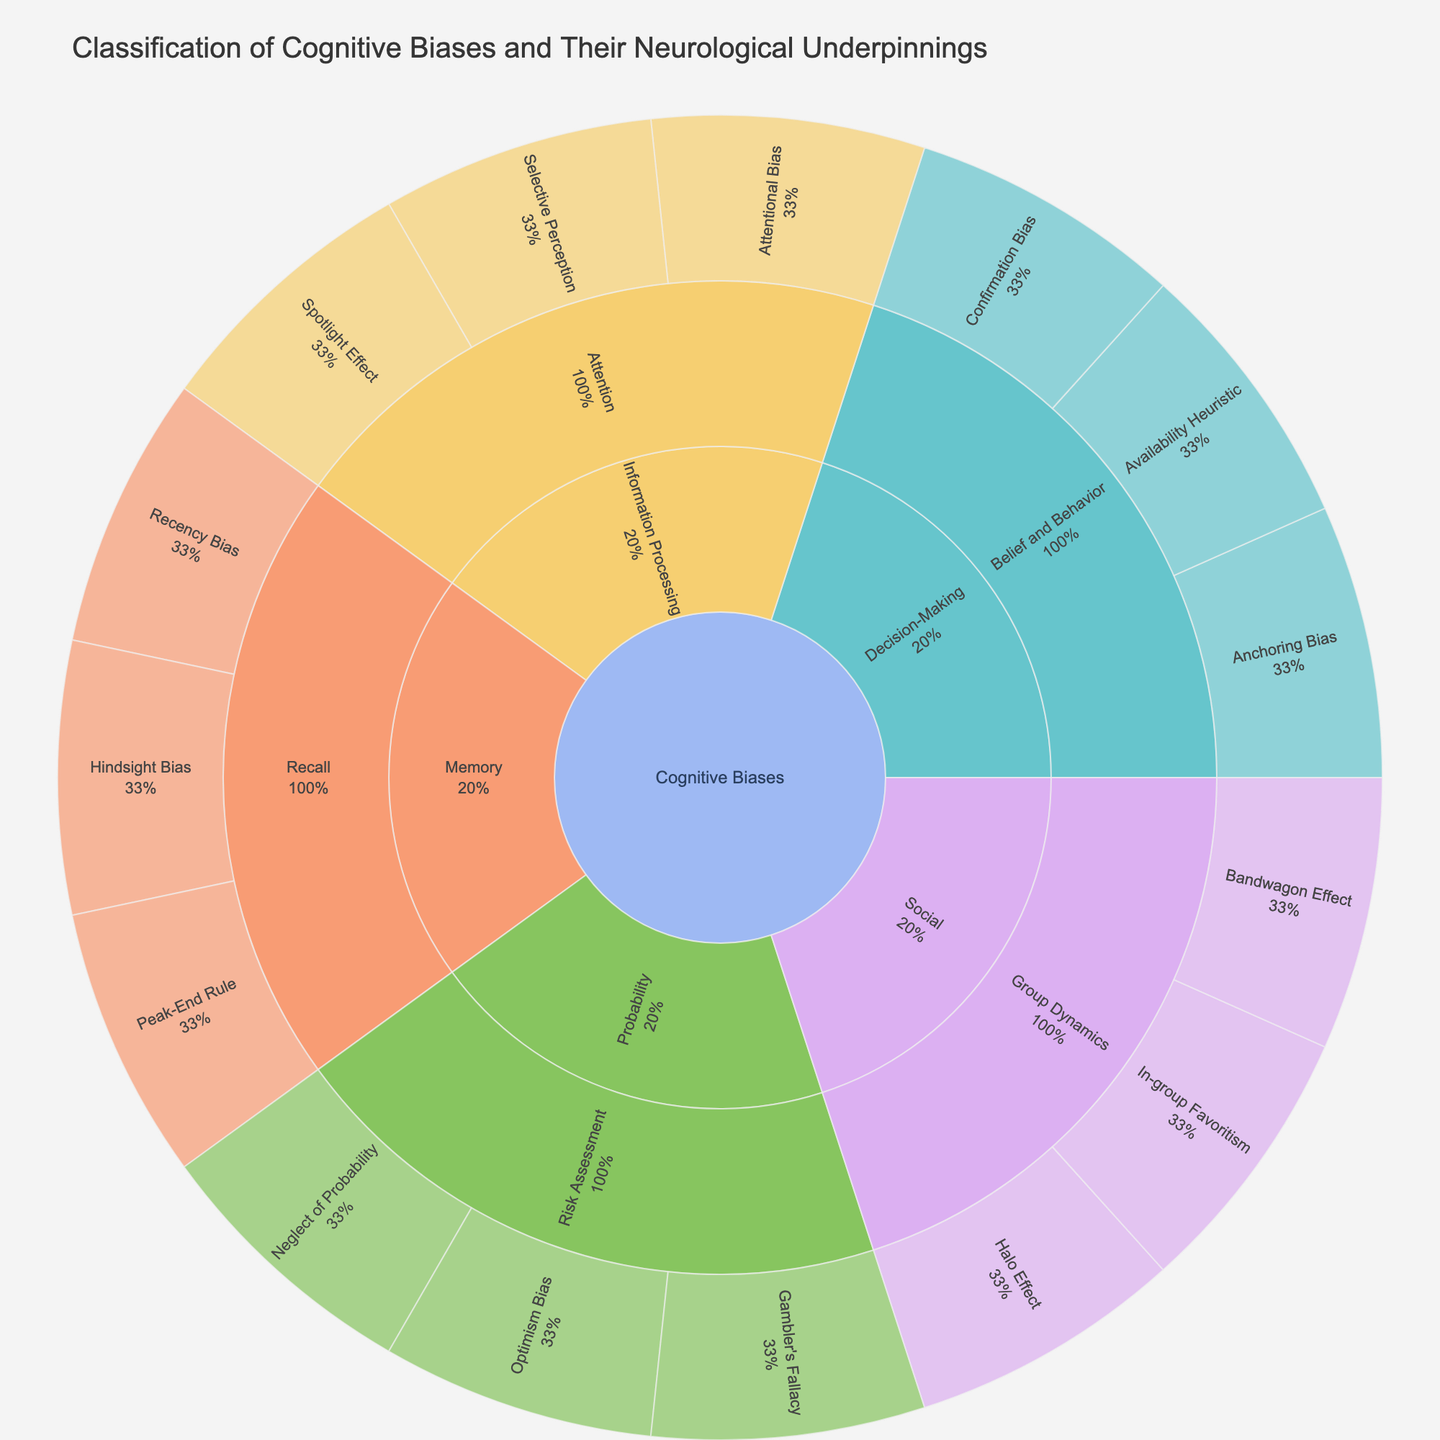what is the title of the sunburst plot? The title is typically located at the top of the plot, indicating the primary focus or purpose of the chart. In this case, it specifies what the plot is about.
Answer: Classification of Cognitive Biases and Their Neurological Underpinnings how many main categories are there in the cognitive biases classification? The sunburst plot shows different segments for each category stemming from the center. The main categories will be the first layer after the center root.
Answer: Four which category has the most subcategories? Examine the number of subdivisions for each main category to determine which has the highest count.
Answer: Decision-Making and Information Processing (Tie - Two each) what percentage of the 'Social' category does 'Group Dynamics' occupy? Look at the 'Social' category and find the segment assigned to 'Group Dynamics,' then refer to the percentage inscribed inside the 'Group Dynamics' segment.
Answer: 100% are 'Attentional Bias' and 'Selective Perception' subcategories of the same category? Check if both 'Attentional Bias' and 'Selective Perception' emerge from the same category in the second layer of the sunburst plot.
Answer: Yes how many biases are in the 'Memory' category? Inspect the number of leaves stemming from the 'Memory' segment within the plot.
Answer: Three which bias belongs to both 'Risk Assessment' and the 'Probability' category? Follow the path branching from 'Probability' that leads to 'Risk Assessment' and identify the biases listed.
Answer: Gambler's Fallacy, Neglect of Probability, Optimism Bias do 'Peak-End Rule' and 'Recency Bias' belong to the same subcategory? Trace the segments connected to 'Peak-End Rule' and 'Recency Bias' and check if they come from the same subcategory within the 'Memory' category.
Answer: Yes how many biases are there under 'Belief and Behavior'? Locate 'Belief and Behavior' under the 'Decision-Making' category, and count the leaves stemming from it.
Answer: Three is the 'Halo Effect' part of the 'Social' or 'Memory' category? Identify in which category 'Halo Effect' is segmented under.
Answer: Social 